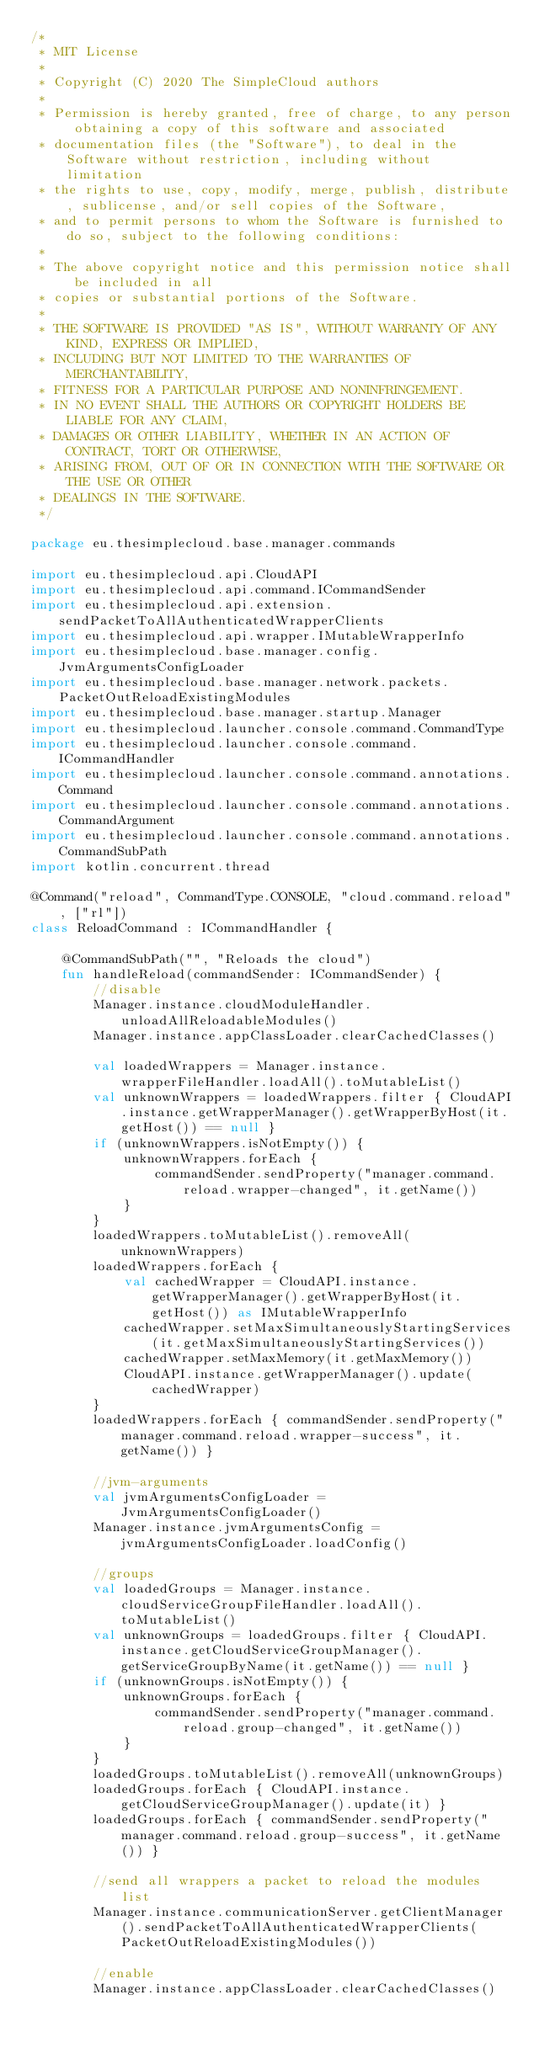Convert code to text. <code><loc_0><loc_0><loc_500><loc_500><_Kotlin_>/*
 * MIT License
 *
 * Copyright (C) 2020 The SimpleCloud authors
 *
 * Permission is hereby granted, free of charge, to any person obtaining a copy of this software and associated
 * documentation files (the "Software"), to deal in the Software without restriction, including without limitation
 * the rights to use, copy, modify, merge, publish, distribute, sublicense, and/or sell copies of the Software,
 * and to permit persons to whom the Software is furnished to do so, subject to the following conditions:
 *
 * The above copyright notice and this permission notice shall be included in all
 * copies or substantial portions of the Software.
 *
 * THE SOFTWARE IS PROVIDED "AS IS", WITHOUT WARRANTY OF ANY KIND, EXPRESS OR IMPLIED,
 * INCLUDING BUT NOT LIMITED TO THE WARRANTIES OF MERCHANTABILITY,
 * FITNESS FOR A PARTICULAR PURPOSE AND NONINFRINGEMENT.
 * IN NO EVENT SHALL THE AUTHORS OR COPYRIGHT HOLDERS BE LIABLE FOR ANY CLAIM,
 * DAMAGES OR OTHER LIABILITY, WHETHER IN AN ACTION OF CONTRACT, TORT OR OTHERWISE,
 * ARISING FROM, OUT OF OR IN CONNECTION WITH THE SOFTWARE OR THE USE OR OTHER
 * DEALINGS IN THE SOFTWARE.
 */

package eu.thesimplecloud.base.manager.commands

import eu.thesimplecloud.api.CloudAPI
import eu.thesimplecloud.api.command.ICommandSender
import eu.thesimplecloud.api.extension.sendPacketToAllAuthenticatedWrapperClients
import eu.thesimplecloud.api.wrapper.IMutableWrapperInfo
import eu.thesimplecloud.base.manager.config.JvmArgumentsConfigLoader
import eu.thesimplecloud.base.manager.network.packets.PacketOutReloadExistingModules
import eu.thesimplecloud.base.manager.startup.Manager
import eu.thesimplecloud.launcher.console.command.CommandType
import eu.thesimplecloud.launcher.console.command.ICommandHandler
import eu.thesimplecloud.launcher.console.command.annotations.Command
import eu.thesimplecloud.launcher.console.command.annotations.CommandArgument
import eu.thesimplecloud.launcher.console.command.annotations.CommandSubPath
import kotlin.concurrent.thread

@Command("reload", CommandType.CONSOLE, "cloud.command.reload", ["rl"])
class ReloadCommand : ICommandHandler {

    @CommandSubPath("", "Reloads the cloud")
    fun handleReload(commandSender: ICommandSender) {
        //disable
        Manager.instance.cloudModuleHandler.unloadAllReloadableModules()
        Manager.instance.appClassLoader.clearCachedClasses()

        val loadedWrappers = Manager.instance.wrapperFileHandler.loadAll().toMutableList()
        val unknownWrappers = loadedWrappers.filter { CloudAPI.instance.getWrapperManager().getWrapperByHost(it.getHost()) == null }
        if (unknownWrappers.isNotEmpty()) {
            unknownWrappers.forEach {
                commandSender.sendProperty("manager.command.reload.wrapper-changed", it.getName())
            }
        }
        loadedWrappers.toMutableList().removeAll(unknownWrappers)
        loadedWrappers.forEach {
            val cachedWrapper = CloudAPI.instance.getWrapperManager().getWrapperByHost(it.getHost()) as IMutableWrapperInfo
            cachedWrapper.setMaxSimultaneouslyStartingServices(it.getMaxSimultaneouslyStartingServices())
            cachedWrapper.setMaxMemory(it.getMaxMemory())
            CloudAPI.instance.getWrapperManager().update(cachedWrapper)
        }
        loadedWrappers.forEach { commandSender.sendProperty("manager.command.reload.wrapper-success", it.getName()) }

        //jvm-arguments
        val jvmArgumentsConfigLoader = JvmArgumentsConfigLoader()
        Manager.instance.jvmArgumentsConfig = jvmArgumentsConfigLoader.loadConfig()

        //groups
        val loadedGroups = Manager.instance.cloudServiceGroupFileHandler.loadAll().toMutableList()
        val unknownGroups = loadedGroups.filter { CloudAPI.instance.getCloudServiceGroupManager().getServiceGroupByName(it.getName()) == null }
        if (unknownGroups.isNotEmpty()) {
            unknownGroups.forEach {
                commandSender.sendProperty("manager.command.reload.group-changed", it.getName())
            }
        }
        loadedGroups.toMutableList().removeAll(unknownGroups)
        loadedGroups.forEach { CloudAPI.instance.getCloudServiceGroupManager().update(it) }
        loadedGroups.forEach { commandSender.sendProperty("manager.command.reload.group-success", it.getName()) }

        //send all wrappers a packet to reload the modules list
        Manager.instance.communicationServer.getClientManager().sendPacketToAllAuthenticatedWrapperClients(PacketOutReloadExistingModules())

        //enable
        Manager.instance.appClassLoader.clearCachedClasses()</code> 